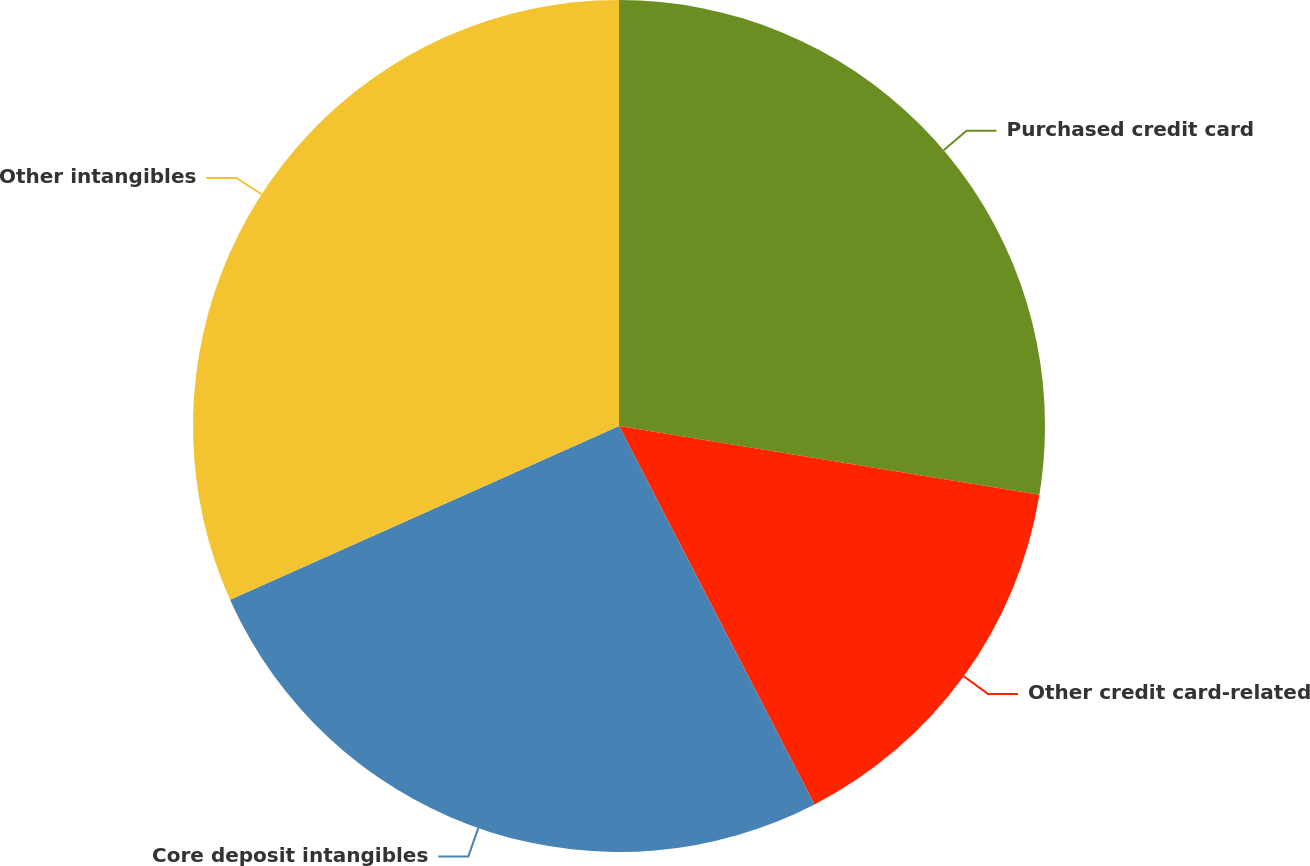<chart> <loc_0><loc_0><loc_500><loc_500><pie_chart><fcel>Purchased credit card<fcel>Other credit card-related<fcel>Core deposit intangibles<fcel>Other intangibles<nl><fcel>27.58%<fcel>14.83%<fcel>25.9%<fcel>31.69%<nl></chart> 